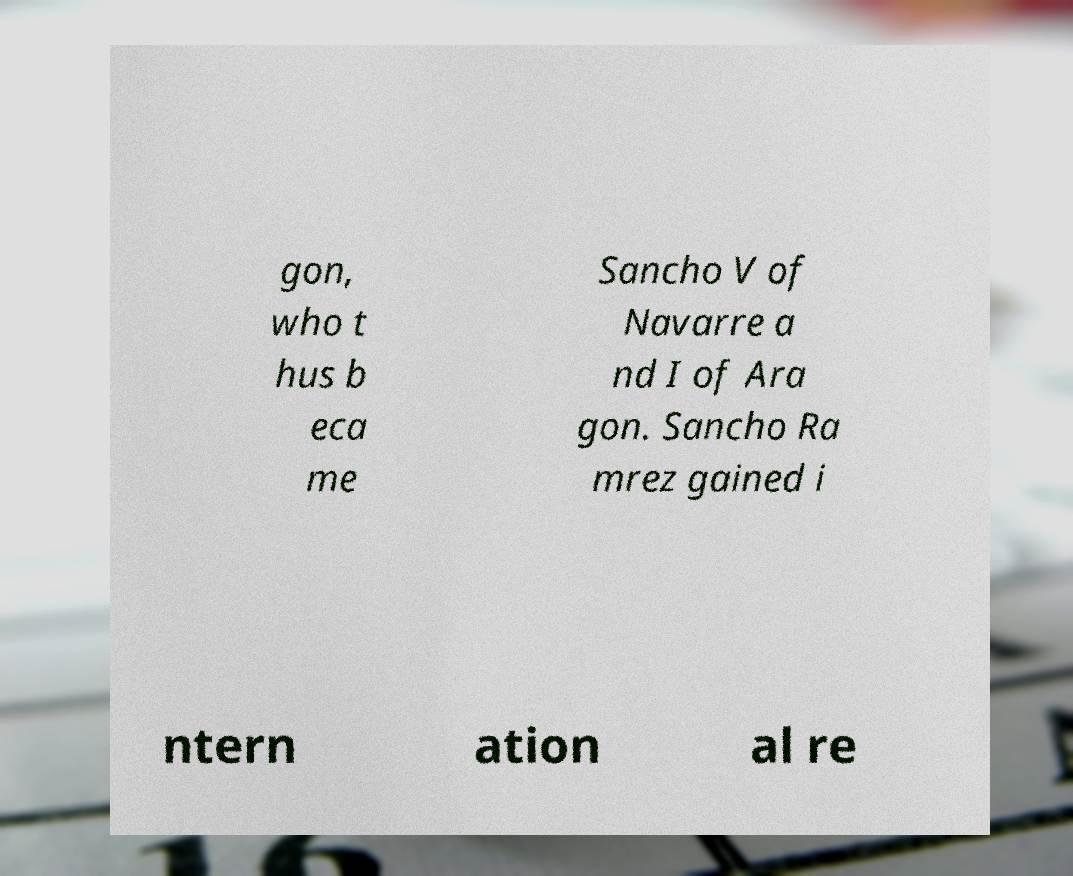There's text embedded in this image that I need extracted. Can you transcribe it verbatim? gon, who t hus b eca me Sancho V of Navarre a nd I of Ara gon. Sancho Ra mrez gained i ntern ation al re 